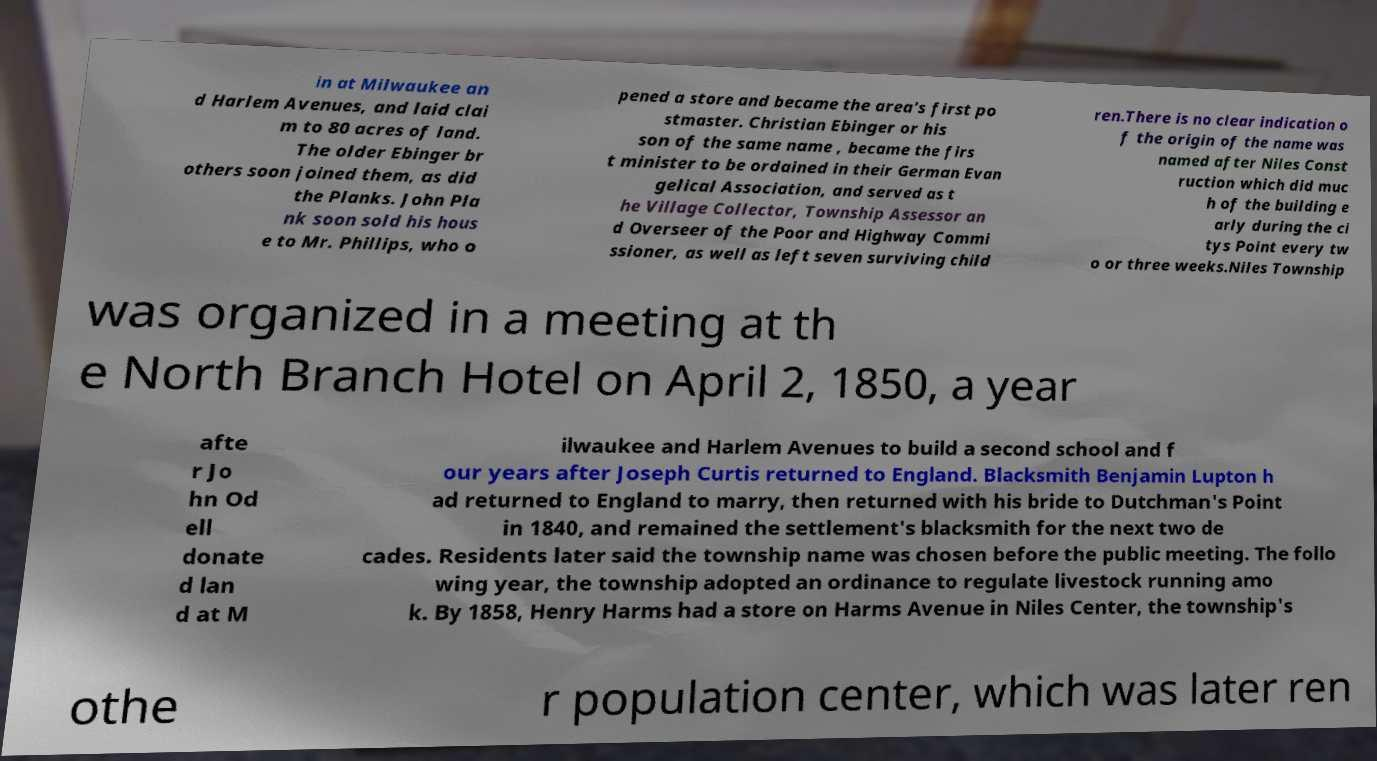Could you assist in decoding the text presented in this image and type it out clearly? in at Milwaukee an d Harlem Avenues, and laid clai m to 80 acres of land. The older Ebinger br others soon joined them, as did the Planks. John Pla nk soon sold his hous e to Mr. Phillips, who o pened a store and became the area's first po stmaster. Christian Ebinger or his son of the same name , became the firs t minister to be ordained in their German Evan gelical Association, and served as t he Village Collector, Township Assessor an d Overseer of the Poor and Highway Commi ssioner, as well as left seven surviving child ren.There is no clear indication o f the origin of the name was named after Niles Const ruction which did muc h of the building e arly during the ci tys Point every tw o or three weeks.Niles Township was organized in a meeting at th e North Branch Hotel on April 2, 1850, a year afte r Jo hn Od ell donate d lan d at M ilwaukee and Harlem Avenues to build a second school and f our years after Joseph Curtis returned to England. Blacksmith Benjamin Lupton h ad returned to England to marry, then returned with his bride to Dutchman's Point in 1840, and remained the settlement's blacksmith for the next two de cades. Residents later said the township name was chosen before the public meeting. The follo wing year, the township adopted an ordinance to regulate livestock running amo k. By 1858, Henry Harms had a store on Harms Avenue in Niles Center, the township's othe r population center, which was later ren 